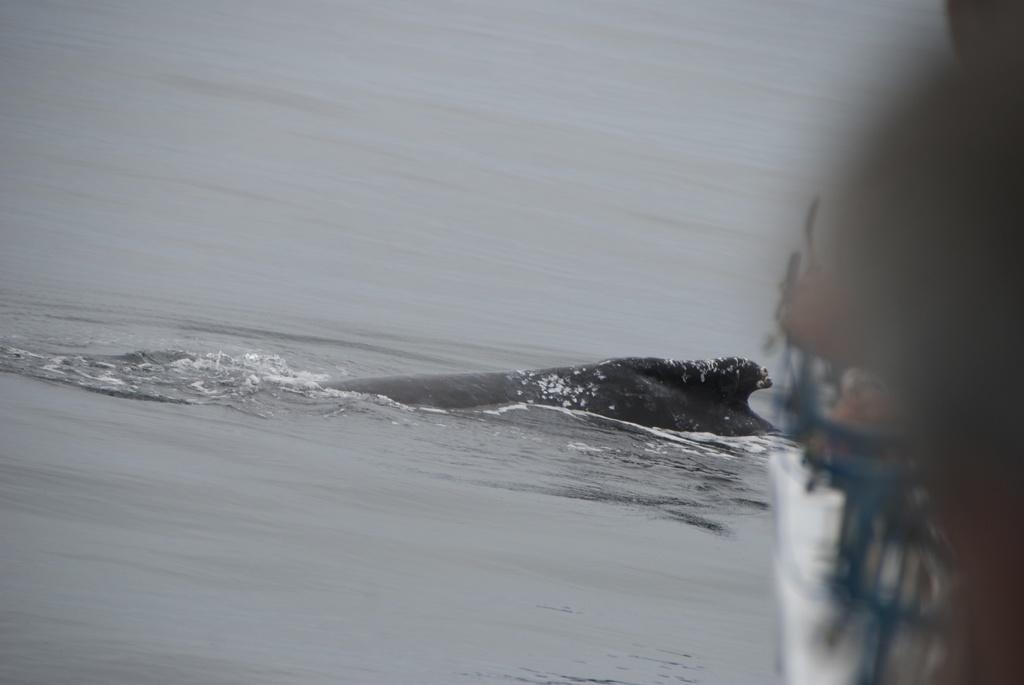Please provide a concise description of this image. In this image, we can see a fish in the water. 